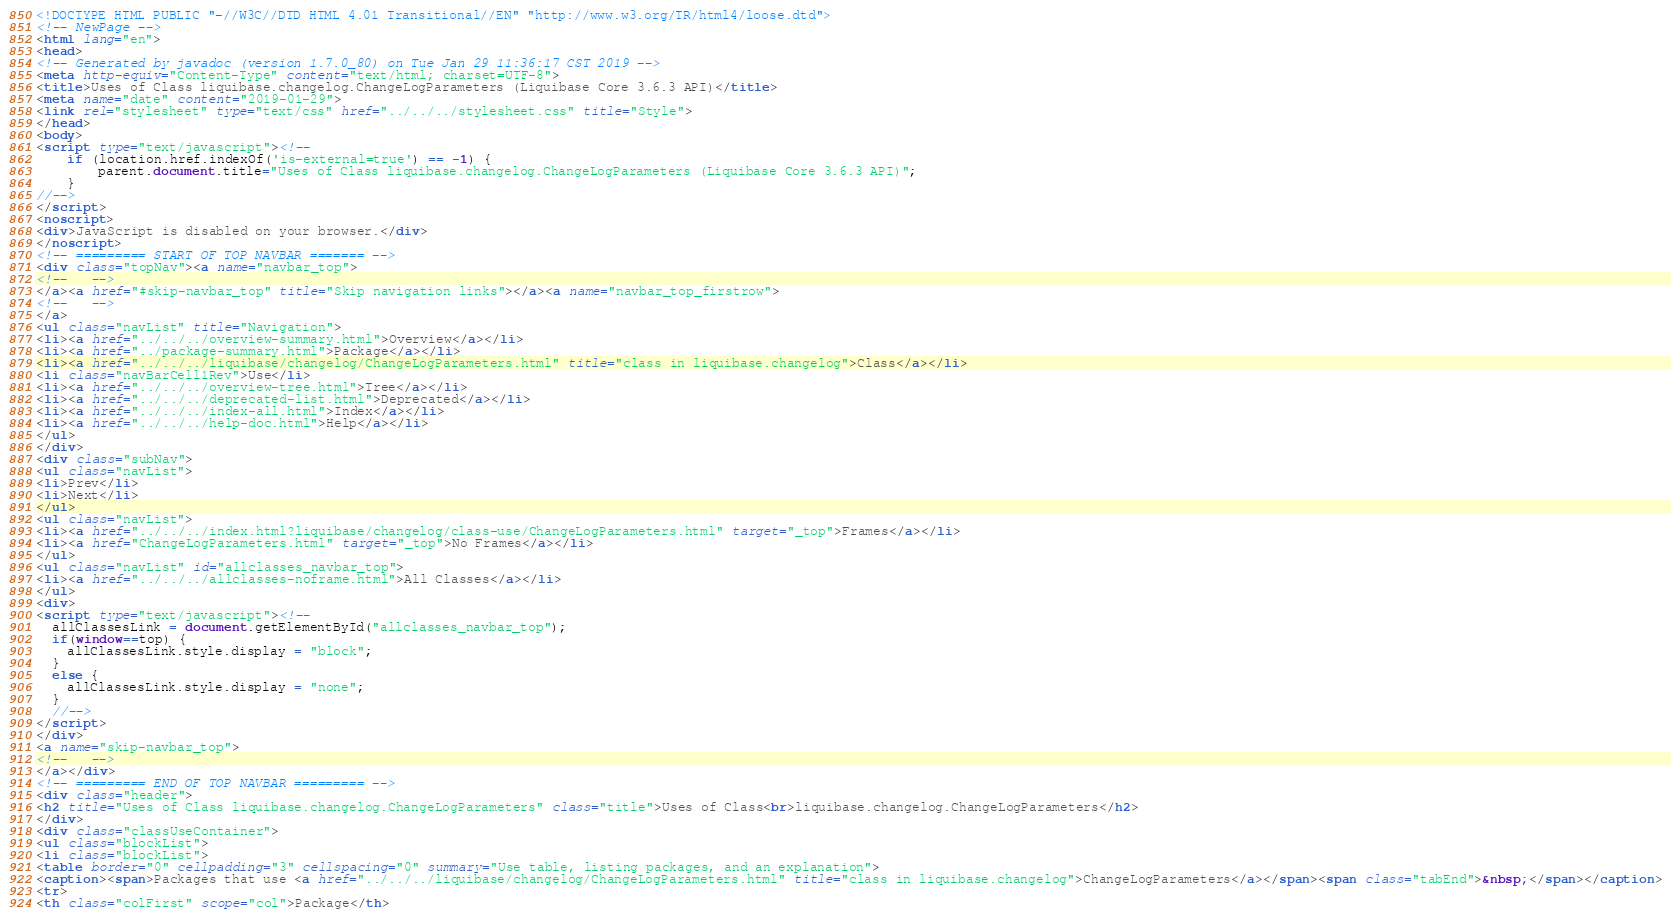Convert code to text. <code><loc_0><loc_0><loc_500><loc_500><_HTML_><!DOCTYPE HTML PUBLIC "-//W3C//DTD HTML 4.01 Transitional//EN" "http://www.w3.org/TR/html4/loose.dtd">
<!-- NewPage -->
<html lang="en">
<head>
<!-- Generated by javadoc (version 1.7.0_80) on Tue Jan 29 11:36:17 CST 2019 -->
<meta http-equiv="Content-Type" content="text/html; charset=UTF-8">
<title>Uses of Class liquibase.changelog.ChangeLogParameters (Liquibase Core 3.6.3 API)</title>
<meta name="date" content="2019-01-29">
<link rel="stylesheet" type="text/css" href="../../../stylesheet.css" title="Style">
</head>
<body>
<script type="text/javascript"><!--
    if (location.href.indexOf('is-external=true') == -1) {
        parent.document.title="Uses of Class liquibase.changelog.ChangeLogParameters (Liquibase Core 3.6.3 API)";
    }
//-->
</script>
<noscript>
<div>JavaScript is disabled on your browser.</div>
</noscript>
<!-- ========= START OF TOP NAVBAR ======= -->
<div class="topNav"><a name="navbar_top">
<!--   -->
</a><a href="#skip-navbar_top" title="Skip navigation links"></a><a name="navbar_top_firstrow">
<!--   -->
</a>
<ul class="navList" title="Navigation">
<li><a href="../../../overview-summary.html">Overview</a></li>
<li><a href="../package-summary.html">Package</a></li>
<li><a href="../../../liquibase/changelog/ChangeLogParameters.html" title="class in liquibase.changelog">Class</a></li>
<li class="navBarCell1Rev">Use</li>
<li><a href="../../../overview-tree.html">Tree</a></li>
<li><a href="../../../deprecated-list.html">Deprecated</a></li>
<li><a href="../../../index-all.html">Index</a></li>
<li><a href="../../../help-doc.html">Help</a></li>
</ul>
</div>
<div class="subNav">
<ul class="navList">
<li>Prev</li>
<li>Next</li>
</ul>
<ul class="navList">
<li><a href="../../../index.html?liquibase/changelog/class-use/ChangeLogParameters.html" target="_top">Frames</a></li>
<li><a href="ChangeLogParameters.html" target="_top">No Frames</a></li>
</ul>
<ul class="navList" id="allclasses_navbar_top">
<li><a href="../../../allclasses-noframe.html">All Classes</a></li>
</ul>
<div>
<script type="text/javascript"><!--
  allClassesLink = document.getElementById("allclasses_navbar_top");
  if(window==top) {
    allClassesLink.style.display = "block";
  }
  else {
    allClassesLink.style.display = "none";
  }
  //-->
</script>
</div>
<a name="skip-navbar_top">
<!--   -->
</a></div>
<!-- ========= END OF TOP NAVBAR ========= -->
<div class="header">
<h2 title="Uses of Class liquibase.changelog.ChangeLogParameters" class="title">Uses of Class<br>liquibase.changelog.ChangeLogParameters</h2>
</div>
<div class="classUseContainer">
<ul class="blockList">
<li class="blockList">
<table border="0" cellpadding="3" cellspacing="0" summary="Use table, listing packages, and an explanation">
<caption><span>Packages that use <a href="../../../liquibase/changelog/ChangeLogParameters.html" title="class in liquibase.changelog">ChangeLogParameters</a></span><span class="tabEnd">&nbsp;</span></caption>
<tr>
<th class="colFirst" scope="col">Package</th></code> 